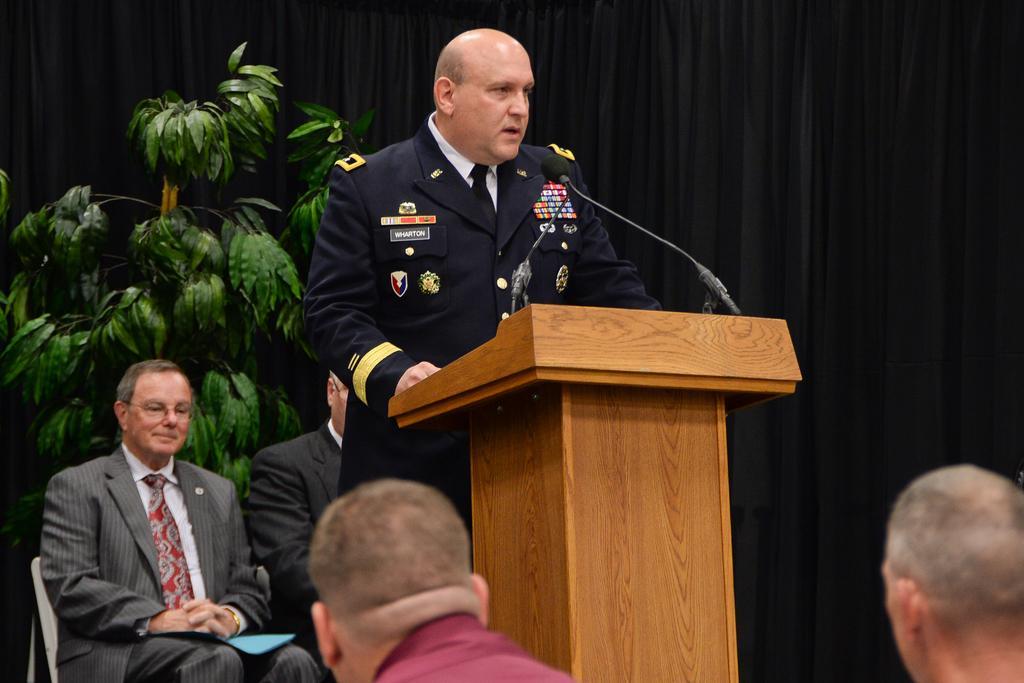In one or two sentences, can you explain what this image depicts? In this picture we can see a man is standing in front of a podium, there is a microphone on the podium, we can see two persons are sitting on chairs, on the left side there is a plant, in the background we can see certain, there are two more persons at the bottom. 